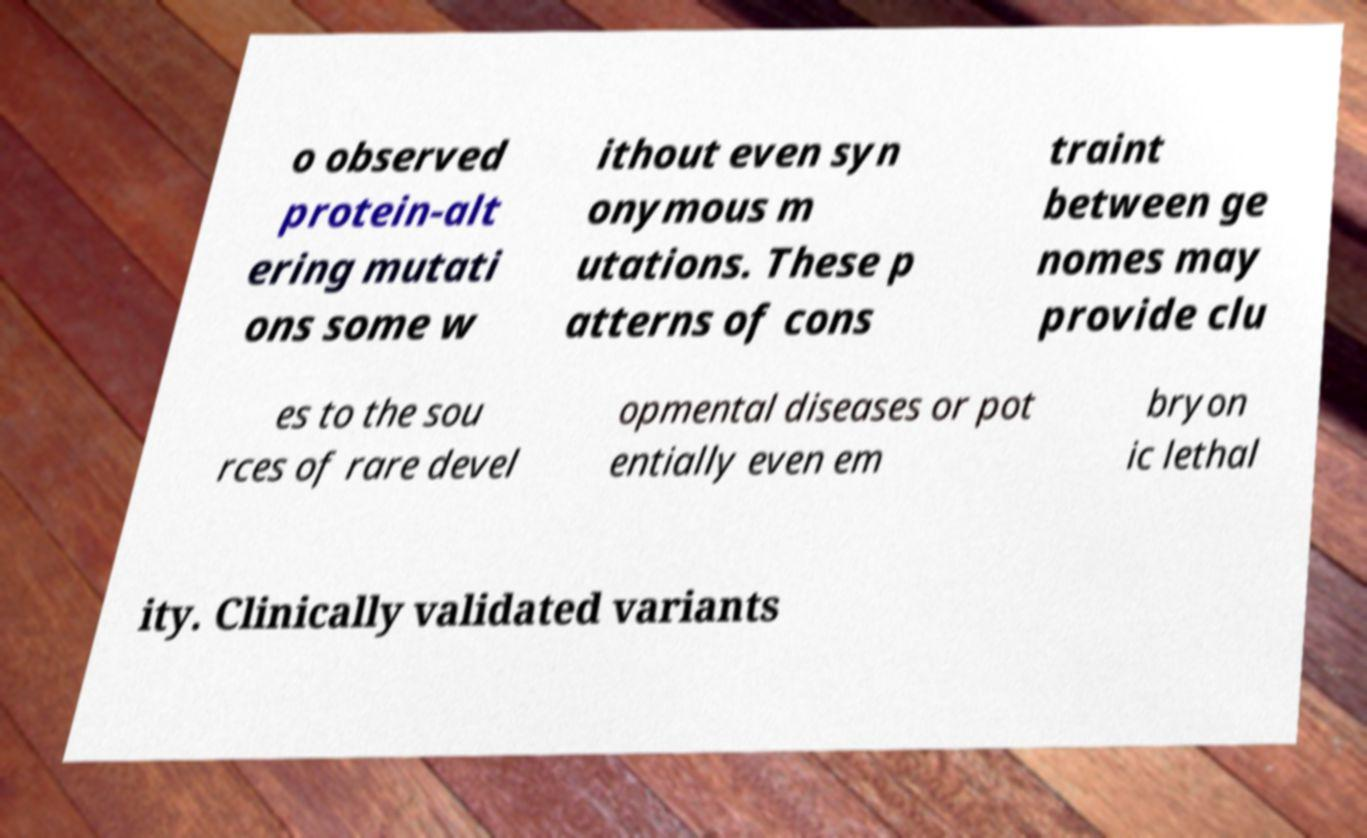What messages or text are displayed in this image? I need them in a readable, typed format. o observed protein-alt ering mutati ons some w ithout even syn onymous m utations. These p atterns of cons traint between ge nomes may provide clu es to the sou rces of rare devel opmental diseases or pot entially even em bryon ic lethal ity. Clinically validated variants 